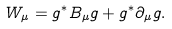<formula> <loc_0><loc_0><loc_500><loc_500>W _ { \mu } = g ^ { * } B _ { \mu } g + g ^ { * } \partial _ { \mu } g .</formula> 